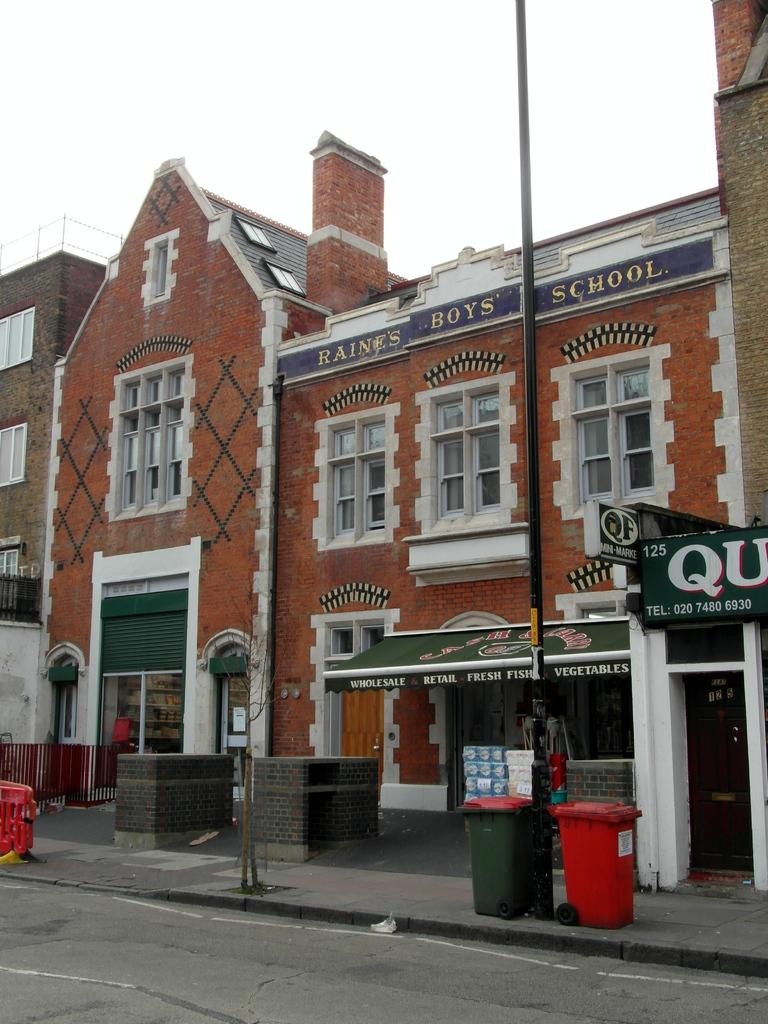What type of pathway is visible in the image? There is a road in the image. What objects are present for waste disposal? There are bins in the image. What structures are present for supporting objects or providing direction? There are poles and a name board in the image. What type of barrier is present in the image? There is a fence in the image. What type of covering is present for protection from sunlight? There is a sun shade in the image. What type of structures are visible with openings for light and ventilation? There are buildings with windows in the image. What is visible in the background of the image? The sky is visible in the background of the image. Is there a stream of mist visible in the image? There is no mention of mist in the provided facts, and therefore it cannot be confirmed as present in the image. Can you see any quicksand in the image? There is no quicksand mentioned or visible in the image. 